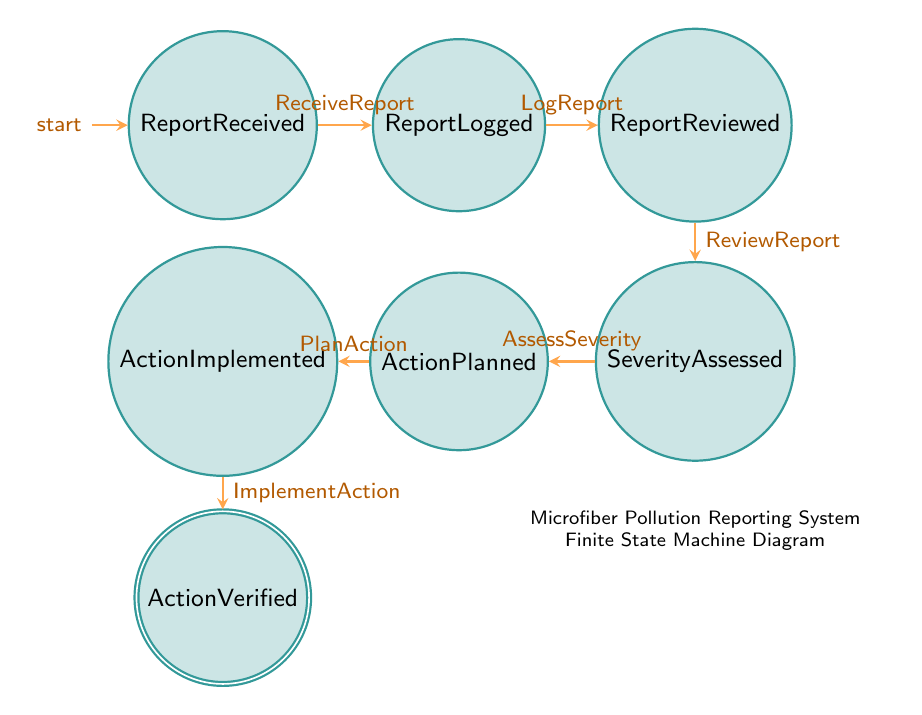What is the first state in the microplastic pollution reporting system? The first state is labeled as "ReportReceived" which indicates the initial point where pollution reports come in.
Answer: ReportReceived How many states are in the diagram? The diagram contains a total of seven states that represent different stages of the microfiber pollution reporting process.
Answer: Seven Which state follows "ReportLogged"? After "ReportLogged," the next state is "ReportReviewed," indicating that the logged reports are now being reviewed by specialists.
Answer: ReportReviewed What transition leads from "SeverityAssessed" to "ActionPlanned"? The transition that moves from "SeverityAssessed" to "ActionPlanned" is called "AssessSeverity," reflecting the decision-making process based on severity assessment.
Answer: AssessSeverity What is the last state in the diagram after actions are taken? The final state in the diagram is "ActionVerified," which represents the verification that the implemented actions were effective.
Answer: ActionVerified Which state is an accepting state in the diagram? The accepting state in this finite state machine is "ActionVerified," signifying the conclusion of the reporting process.
Answer: ActionVerified What is the transition that occurs after "ImplementAction"? The transition following "ImplementAction" leads to "ActionVerified," indicating that actions for addressing microfiber pollution have been implemented and are now under review.
Answer: ActionVerified 